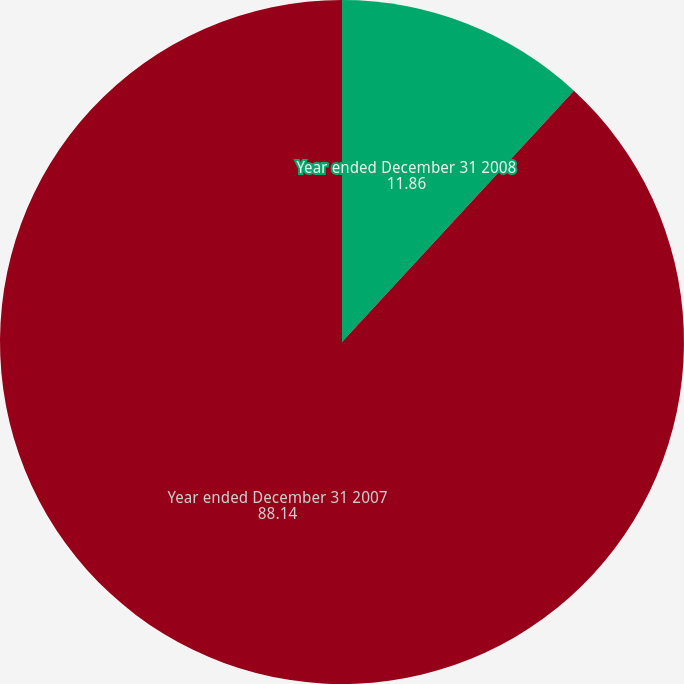<chart> <loc_0><loc_0><loc_500><loc_500><pie_chart><fcel>Year ended December 31 2008<fcel>Year ended December 31 2007<nl><fcel>11.86%<fcel>88.14%<nl></chart> 